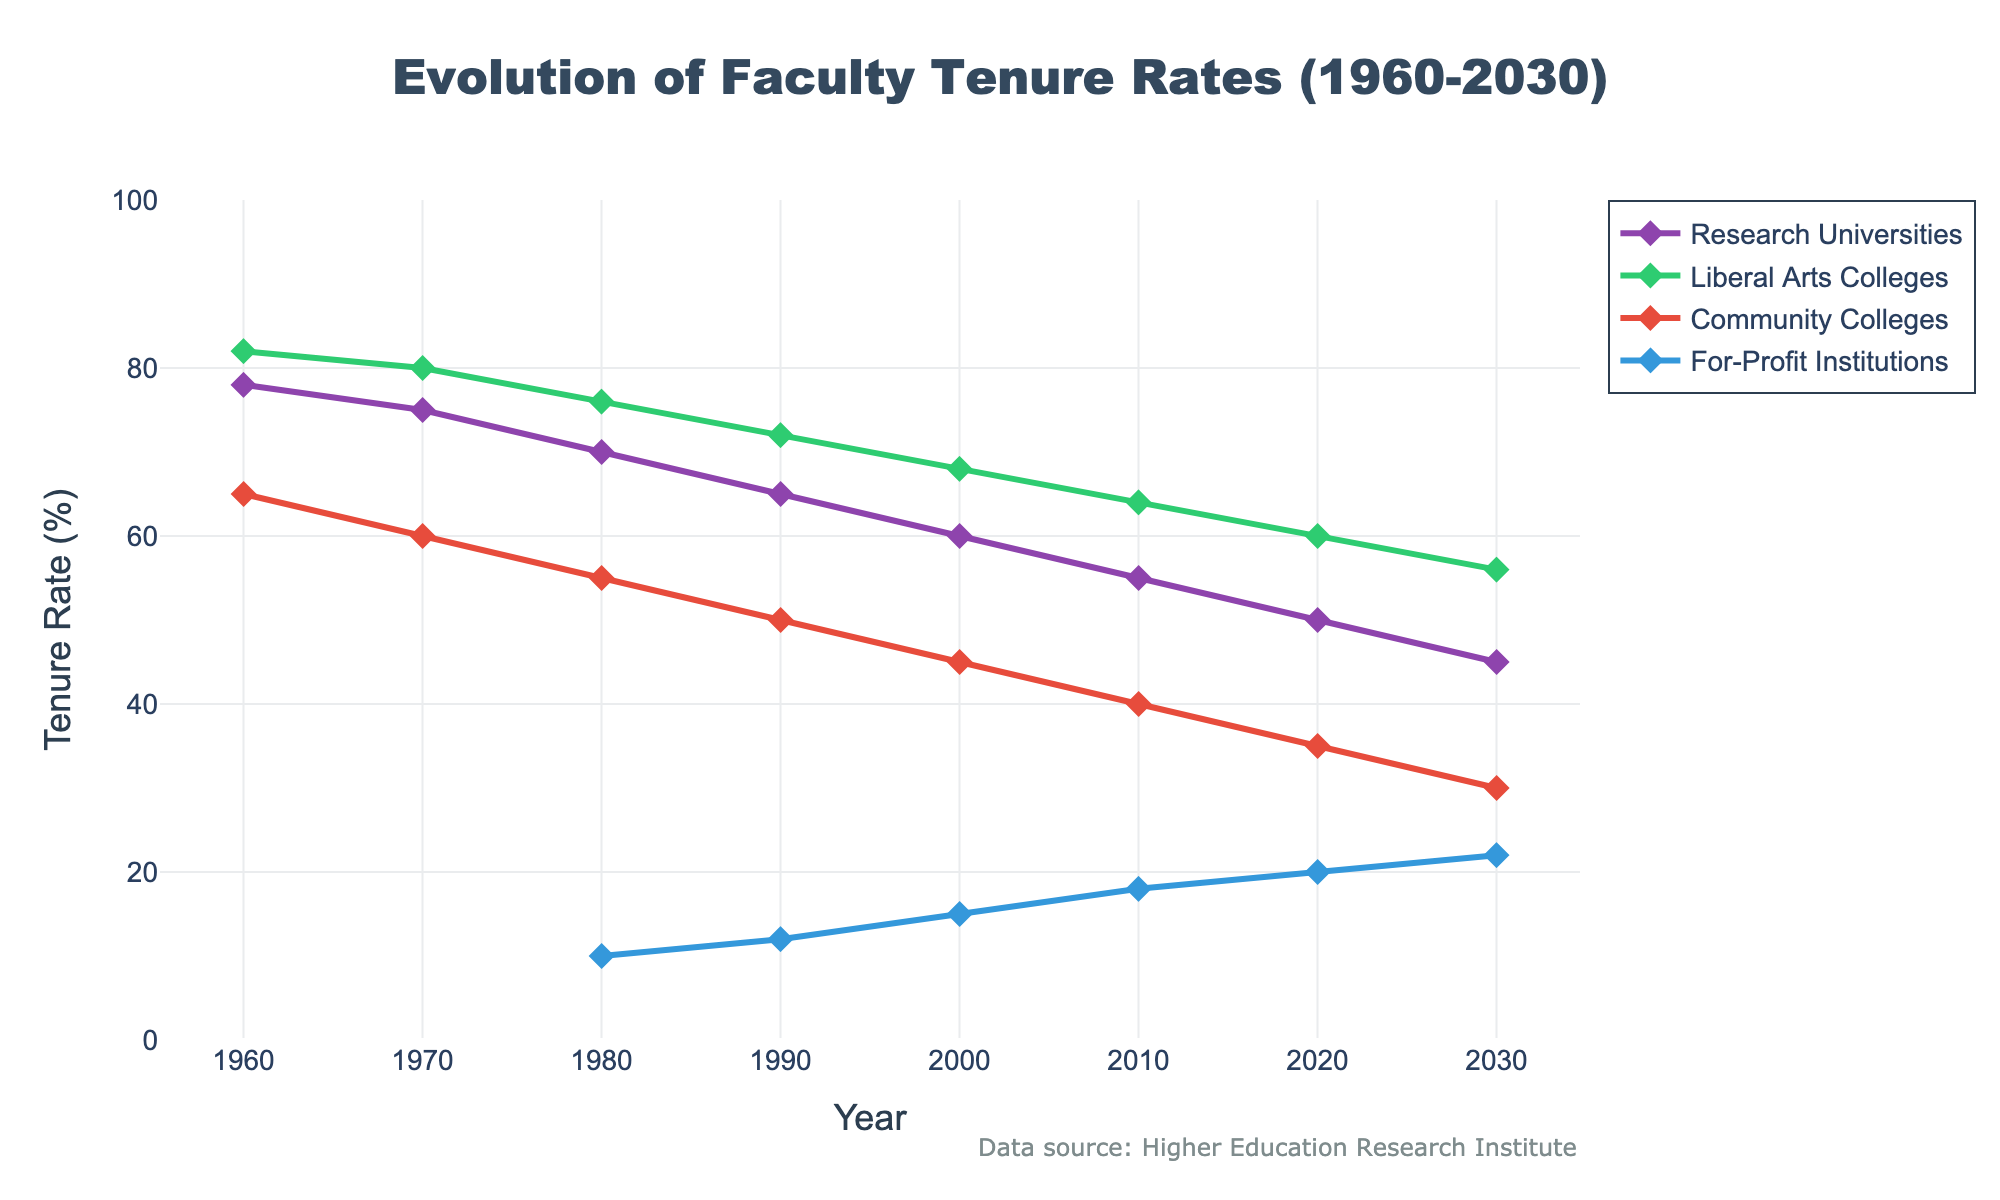What was the tenure rate decrease for Research Universities from 1960 to 2000? The tenure rate for Research Universities in 1960 was 78%. By 2000, the tenure rate had decreased to 60%. The decrease is calculated as 78% - 60% = 18%
Answer: 18% Which institution type had the highest tenure rate in 1990? In 1990, the tenure rates were 65% for Research Universities, 72% for Liberal Arts Colleges, 50% for Community Colleges, and 12% for For-Profit Institutions. The highest tenure rate was for Liberal Arts Colleges at 72%
Answer: Liberal Arts Colleges Which year did Community Colleges experience the largest decade-over-decade tenure rate drop, and by how much? Checking each decade, the tenure rates for Community Colleges decreased as follows: 1960 to 1970 (65% to 60%), 1970 to 1980 (60% to 55%), 1980 to 1990 (55% to 50%), 1990 to 2000 (50% to 45%), 2000 to 2010 (45% to 40%), and 2010 to 2020 (40% to 35%). The largest drop was from 1960 to 1970 with a decrease of 5%
Answer: 1970, 5% What is the average tenure rate for For-Profit Institutions across the available years? The tenure rates for For-Profit Institutions across the available years (1980 to 2030) are 10%, 12%, 15%, 18%, 20%, and 22%. Summing these rates: 10 + 12 + 15 + 18 + 20 + 22 = 97. The average is 97 / 6 = 16.17
Answer: 16.17 